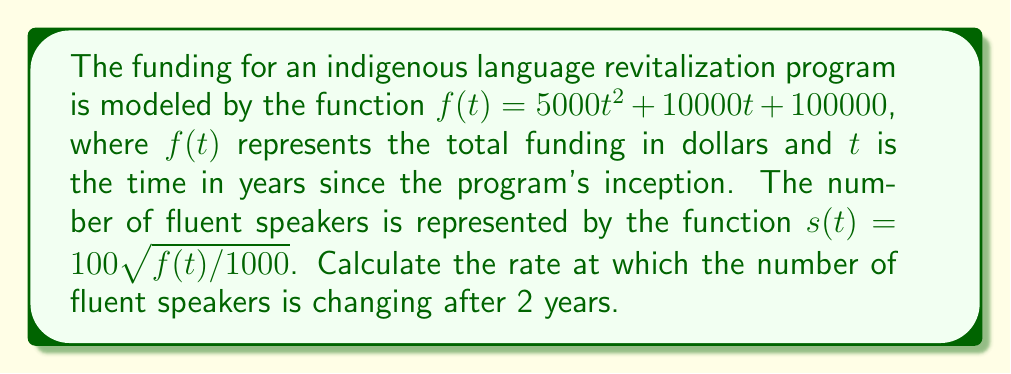What is the answer to this math problem? To solve this problem, we need to follow these steps:

1) First, we need to find $s(t)$ in terms of $t$:
   $s(t) = 100\sqrt{f(t)/1000}$
   $s(t) = 100\sqrt{(5000t^2 + 10000t + 100000)/1000}$
   $s(t) = 100\sqrt{5t^2 + 10t + 100}$

2) Now, we need to find the derivative of $s(t)$ with respect to $t$:
   $$\frac{ds}{dt} = 100 \cdot \frac{1}{2\sqrt{5t^2 + 10t + 100}} \cdot (10t + 10)$$
   $$\frac{ds}{dt} = \frac{500t + 500}{\sqrt{5t^2 + 10t + 100}}$$

3) We want to find the rate of change after 2 years, so we need to evaluate $\frac{ds}{dt}$ at $t = 2$:
   $$\frac{ds}{dt}|_{t=2} = \frac{500(2) + 500}{\sqrt{5(2)^2 + 10(2) + 100}}$$
   $$= \frac{1500}{\sqrt{20 + 20 + 100}}$$
   $$= \frac{1500}{\sqrt{140}}$$
   $$\approx 126.78$$

Therefore, after 2 years, the number of fluent speakers is increasing at a rate of approximately 126.78 speakers per year.
Answer: $\frac{1500}{\sqrt{140}} \approx 126.78$ speakers/year 